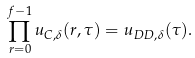Convert formula to latex. <formula><loc_0><loc_0><loc_500><loc_500>\prod _ { r = 0 } ^ { f - 1 } u _ { C , \delta } ( r , \tau ) = u _ { D D , \delta } ( \tau ) .</formula> 